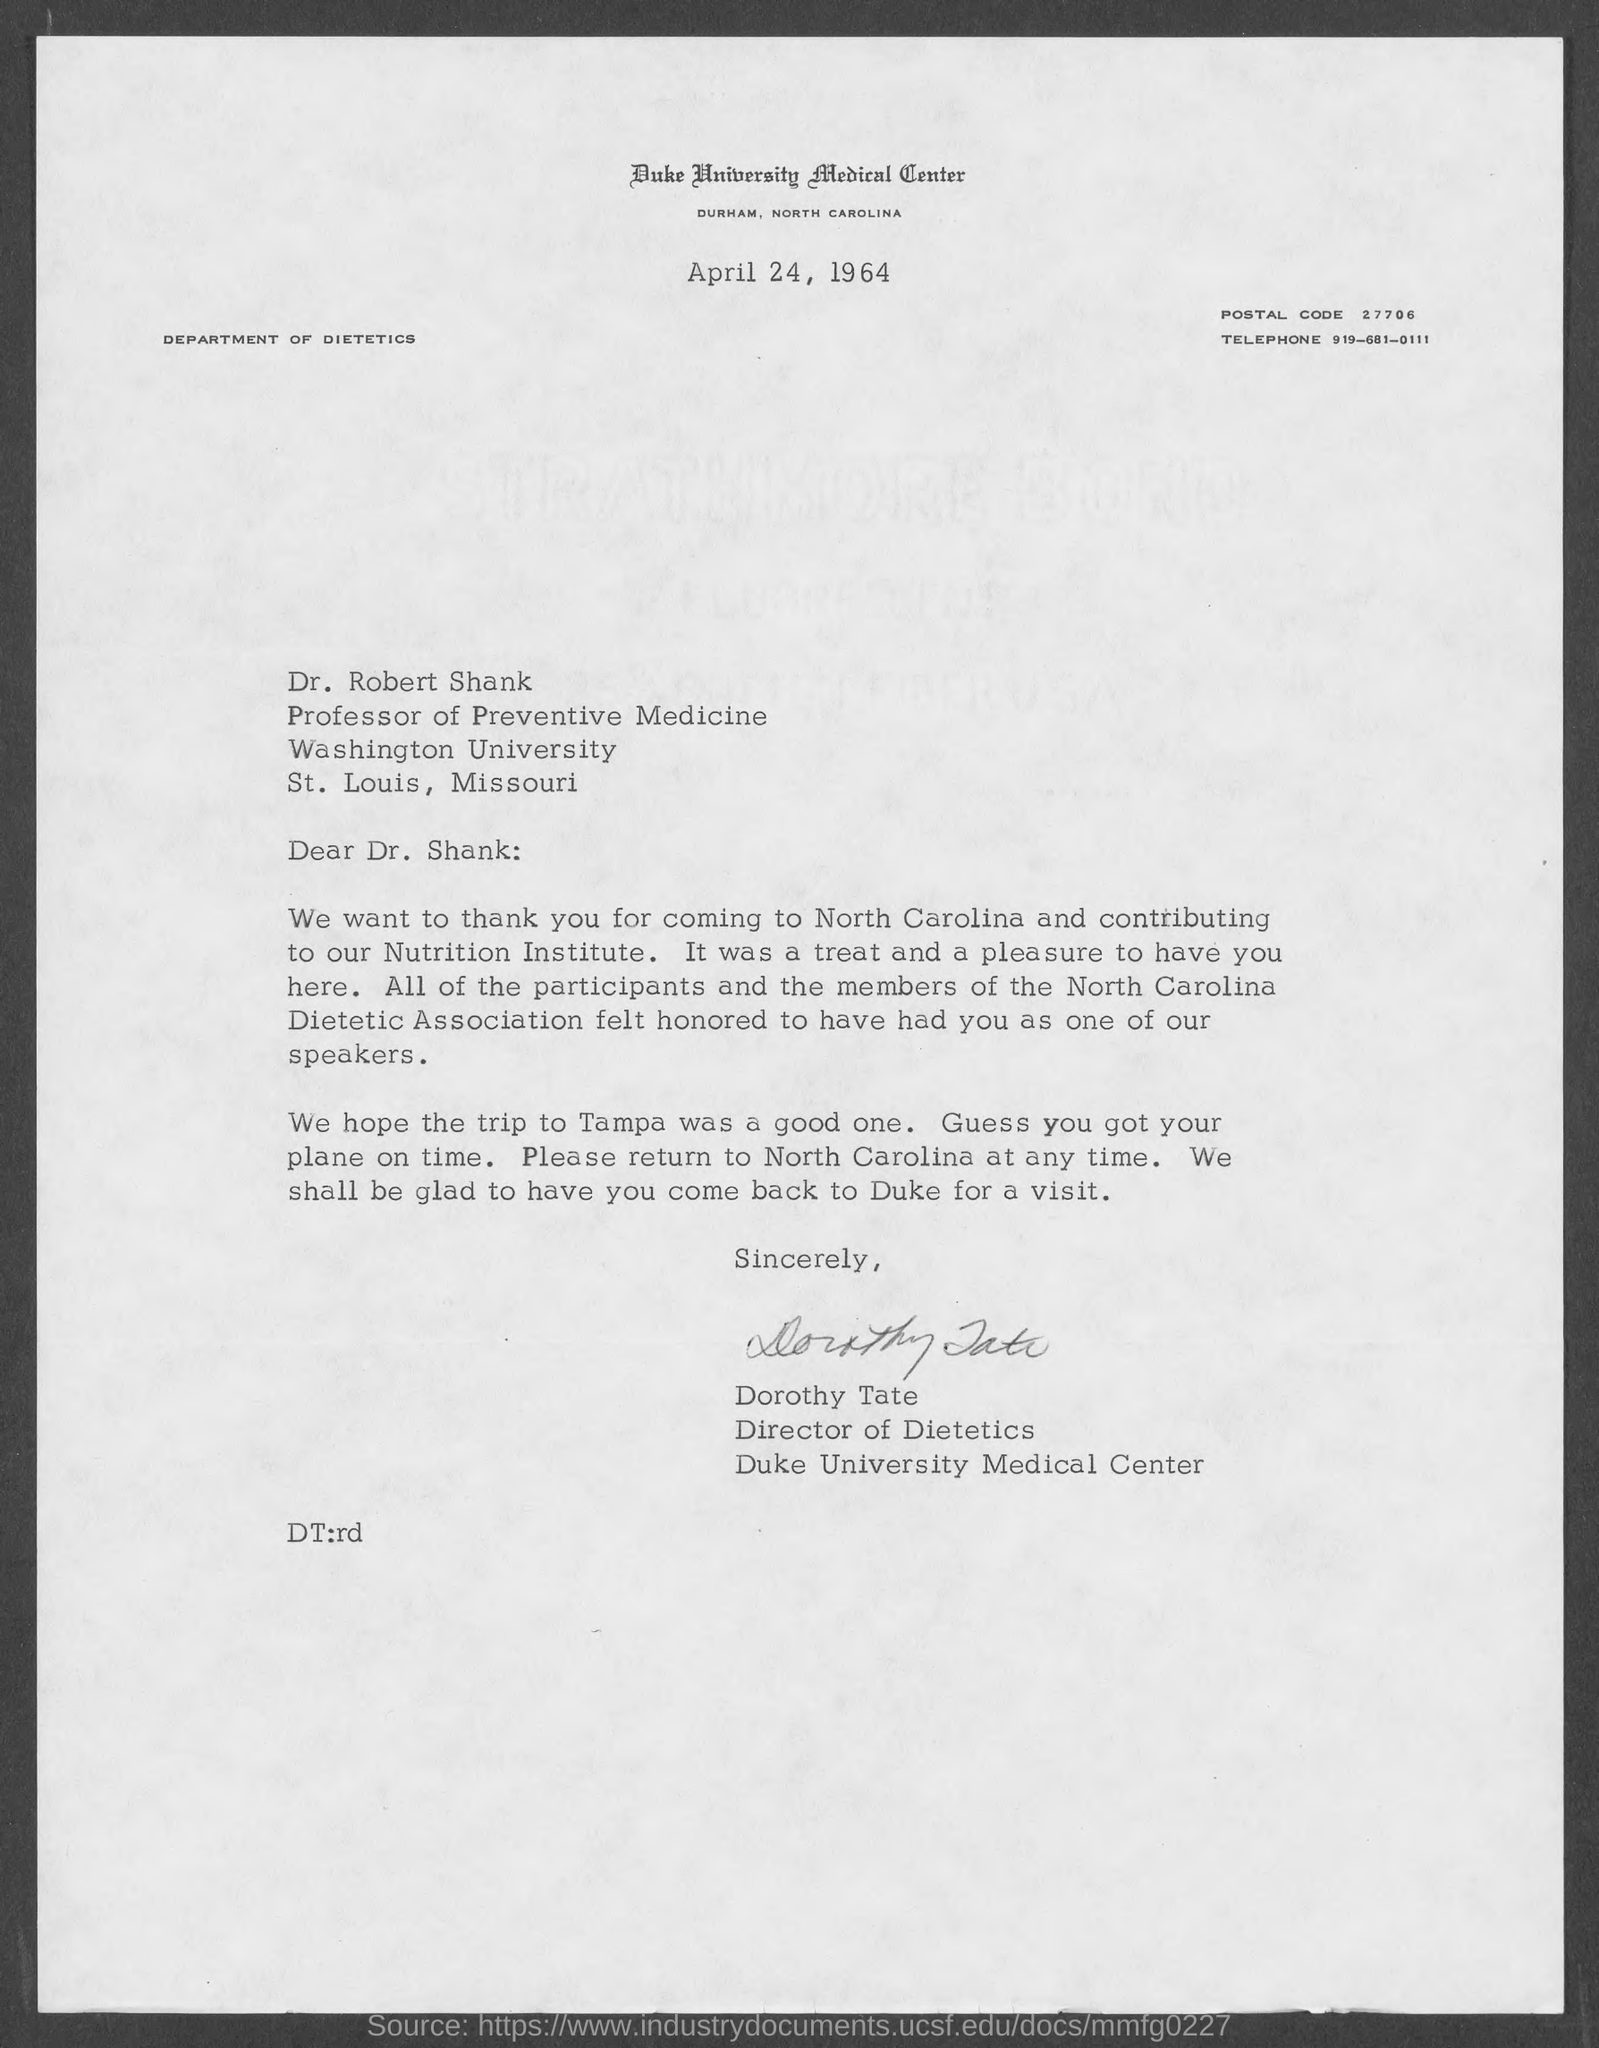What is the postal code ?
Give a very brief answer. 27706. What is the telephone number ?
Make the answer very short. 919-681-0111. To whom this letter is written?
Provide a short and direct response. Dr.Shank. What is the designation of dr. robert shank  ?
Offer a terse response. Professor of Preventive Medicine. This letter is written by whom ?
Your answer should be compact. Dorothy Tate. What is the designation of dorothy tate
Provide a short and direct response. Director of Dietetics. Where is duke university medical center located ?
Keep it short and to the point. Durham , north Carolina. Where is washington university located ?
Offer a very short reply. St. Louis, Missouri. 